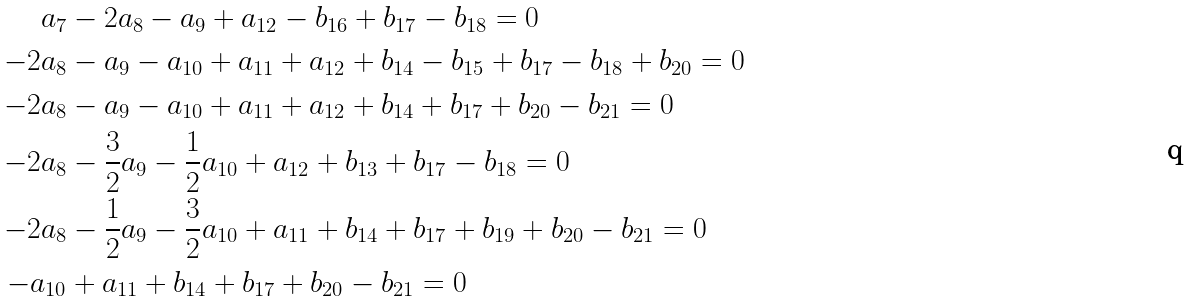Convert formula to latex. <formula><loc_0><loc_0><loc_500><loc_500>a _ { 7 } & - 2 a _ { 8 } - a _ { 9 } + a _ { 1 2 } - b _ { 1 6 } + b _ { 1 7 } - b _ { 1 8 } = 0 \\ - 2 a _ { 8 } & - a _ { 9 } - a _ { 1 0 } + a _ { 1 1 } + a _ { 1 2 } + b _ { 1 4 } - b _ { 1 5 } + b _ { 1 7 } - b _ { 1 8 } + b _ { 2 0 } = 0 \\ - 2 a _ { 8 } & - a _ { 9 } - a _ { 1 0 } + a _ { 1 1 } + a _ { 1 2 } + b _ { 1 4 } + b _ { 1 7 } + b _ { 2 0 } - b _ { 2 1 } = 0 \\ - 2 a _ { 8 } & - \frac { 3 } { 2 } a _ { 9 } - \frac { 1 } { 2 } a _ { 1 0 } + a _ { 1 2 } + b _ { 1 3 } + b _ { 1 7 } - b _ { 1 8 } = 0 \\ - 2 a _ { 8 } & - \frac { 1 } { 2 } a _ { 9 } - \frac { 3 } { 2 } a _ { 1 0 } + a _ { 1 1 } + b _ { 1 4 } + b _ { 1 7 } + b _ { 1 9 } + b _ { 2 0 } - b _ { 2 1 } = 0 \\ - a _ { 1 0 } & + a _ { 1 1 } + b _ { 1 4 } + b _ { 1 7 } + b _ { 2 0 } - b _ { 2 1 } = 0</formula> 